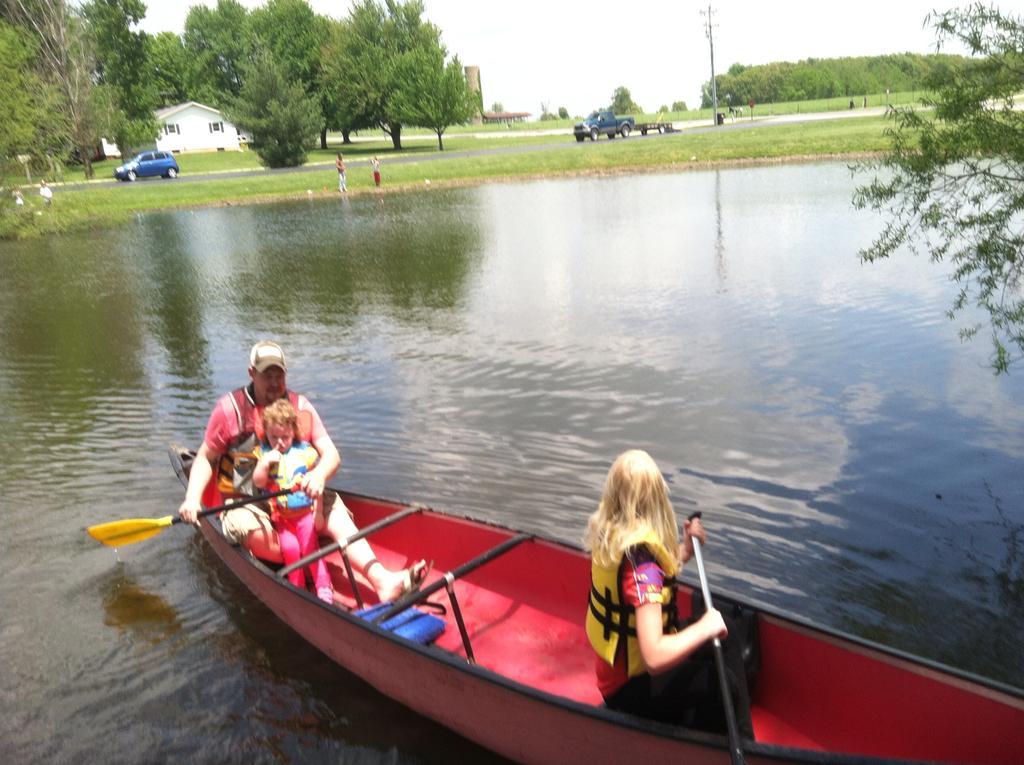How would you summarize this image in a sentence or two? At the bottom of the image we can see some persons are sitting on a boat and holding an object. In the background of the image we can see some plants, persons, boards, house, building, pole, trees, grass, water. At the top of the image we can see the sky. 